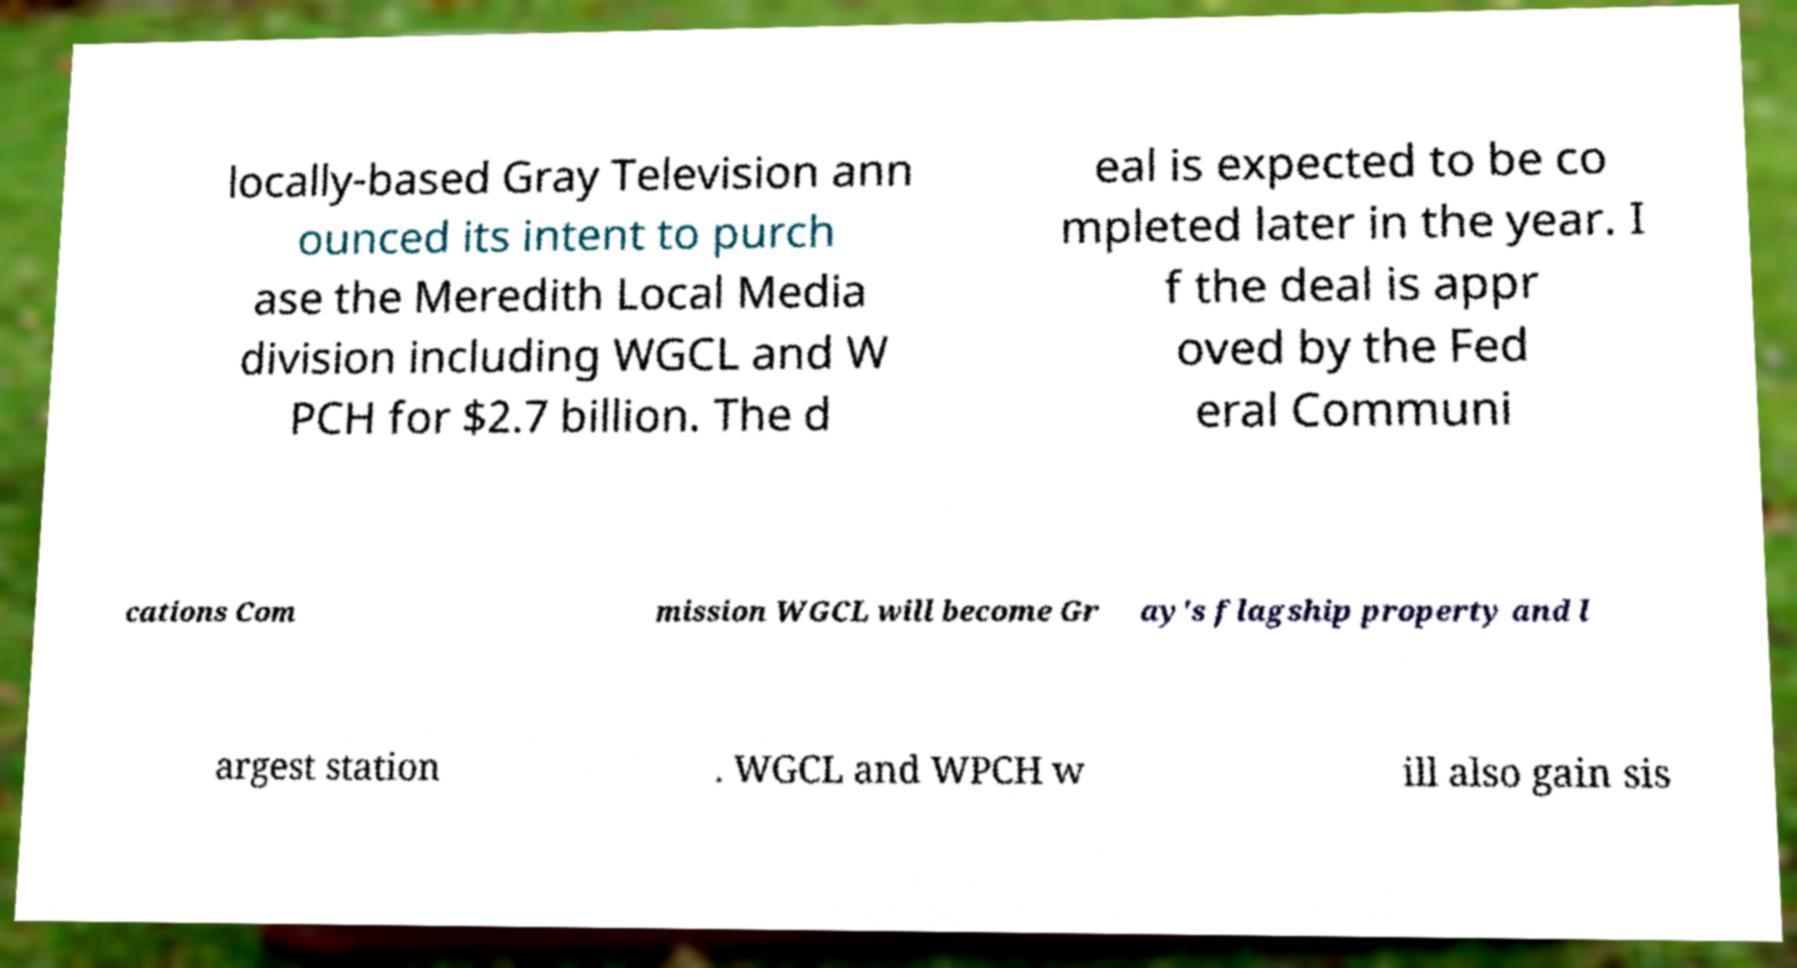Could you extract and type out the text from this image? locally-based Gray Television ann ounced its intent to purch ase the Meredith Local Media division including WGCL and W PCH for $2.7 billion. The d eal is expected to be co mpleted later in the year. I f the deal is appr oved by the Fed eral Communi cations Com mission WGCL will become Gr ay's flagship property and l argest station . WGCL and WPCH w ill also gain sis 